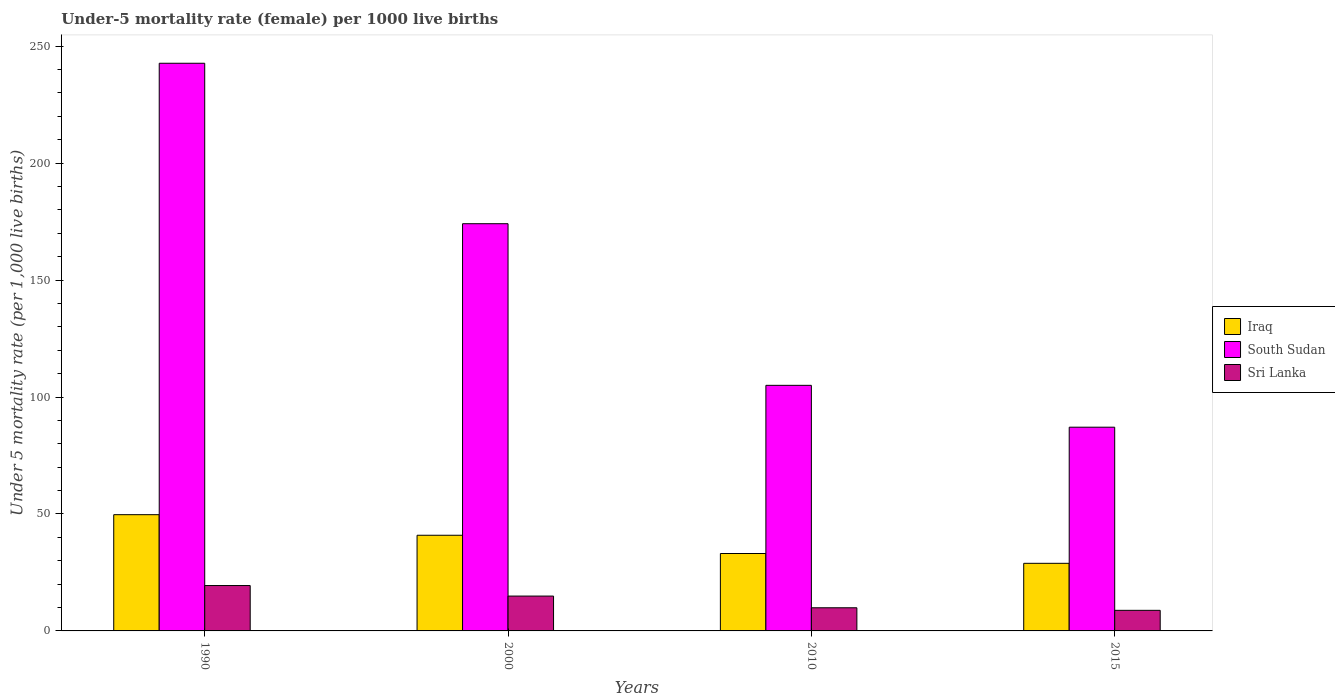How many different coloured bars are there?
Your answer should be compact. 3. Are the number of bars on each tick of the X-axis equal?
Ensure brevity in your answer.  Yes. What is the label of the 1st group of bars from the left?
Offer a terse response. 1990. In which year was the under-five mortality rate in Iraq minimum?
Your answer should be very brief. 2015. What is the total under-five mortality rate in South Sudan in the graph?
Offer a terse response. 608.9. What is the difference between the under-five mortality rate in Iraq in 2000 and that in 2010?
Keep it short and to the point. 7.8. What is the difference between the under-five mortality rate in South Sudan in 2010 and the under-five mortality rate in Sri Lanka in 2015?
Your answer should be compact. 96.2. What is the average under-five mortality rate in South Sudan per year?
Ensure brevity in your answer.  152.22. In the year 2015, what is the difference between the under-five mortality rate in Sri Lanka and under-five mortality rate in Iraq?
Your answer should be compact. -20.1. In how many years, is the under-five mortality rate in South Sudan greater than 170?
Your answer should be very brief. 2. What is the ratio of the under-five mortality rate in Iraq in 1990 to that in 2010?
Your answer should be compact. 1.5. Is the under-five mortality rate in South Sudan in 2000 less than that in 2015?
Provide a succinct answer. No. What is the difference between the highest and the second highest under-five mortality rate in South Sudan?
Your answer should be compact. 68.6. What is the difference between the highest and the lowest under-five mortality rate in Sri Lanka?
Offer a very short reply. 10.6. What does the 1st bar from the left in 2000 represents?
Provide a short and direct response. Iraq. What does the 1st bar from the right in 2015 represents?
Offer a terse response. Sri Lanka. How many years are there in the graph?
Make the answer very short. 4. Are the values on the major ticks of Y-axis written in scientific E-notation?
Your response must be concise. No. Does the graph contain any zero values?
Ensure brevity in your answer.  No. Does the graph contain grids?
Your answer should be very brief. No. Where does the legend appear in the graph?
Offer a terse response. Center right. How many legend labels are there?
Give a very brief answer. 3. How are the legend labels stacked?
Your response must be concise. Vertical. What is the title of the graph?
Make the answer very short. Under-5 mortality rate (female) per 1000 live births. What is the label or title of the X-axis?
Ensure brevity in your answer.  Years. What is the label or title of the Y-axis?
Your answer should be compact. Under 5 mortality rate (per 1,0 live births). What is the Under 5 mortality rate (per 1,000 live births) of Iraq in 1990?
Offer a very short reply. 49.7. What is the Under 5 mortality rate (per 1,000 live births) of South Sudan in 1990?
Offer a terse response. 242.7. What is the Under 5 mortality rate (per 1,000 live births) in Sri Lanka in 1990?
Your answer should be compact. 19.4. What is the Under 5 mortality rate (per 1,000 live births) of Iraq in 2000?
Give a very brief answer. 40.9. What is the Under 5 mortality rate (per 1,000 live births) of South Sudan in 2000?
Offer a terse response. 174.1. What is the Under 5 mortality rate (per 1,000 live births) in Sri Lanka in 2000?
Your response must be concise. 14.9. What is the Under 5 mortality rate (per 1,000 live births) of Iraq in 2010?
Give a very brief answer. 33.1. What is the Under 5 mortality rate (per 1,000 live births) in South Sudan in 2010?
Provide a succinct answer. 105. What is the Under 5 mortality rate (per 1,000 live births) in Sri Lanka in 2010?
Make the answer very short. 9.9. What is the Under 5 mortality rate (per 1,000 live births) of Iraq in 2015?
Your response must be concise. 28.9. What is the Under 5 mortality rate (per 1,000 live births) in South Sudan in 2015?
Your answer should be very brief. 87.1. Across all years, what is the maximum Under 5 mortality rate (per 1,000 live births) of Iraq?
Provide a succinct answer. 49.7. Across all years, what is the maximum Under 5 mortality rate (per 1,000 live births) of South Sudan?
Make the answer very short. 242.7. Across all years, what is the maximum Under 5 mortality rate (per 1,000 live births) of Sri Lanka?
Your response must be concise. 19.4. Across all years, what is the minimum Under 5 mortality rate (per 1,000 live births) of Iraq?
Provide a short and direct response. 28.9. Across all years, what is the minimum Under 5 mortality rate (per 1,000 live births) of South Sudan?
Provide a succinct answer. 87.1. What is the total Under 5 mortality rate (per 1,000 live births) in Iraq in the graph?
Keep it short and to the point. 152.6. What is the total Under 5 mortality rate (per 1,000 live births) in South Sudan in the graph?
Give a very brief answer. 608.9. What is the total Under 5 mortality rate (per 1,000 live births) in Sri Lanka in the graph?
Your answer should be compact. 53. What is the difference between the Under 5 mortality rate (per 1,000 live births) of Iraq in 1990 and that in 2000?
Your response must be concise. 8.8. What is the difference between the Under 5 mortality rate (per 1,000 live births) in South Sudan in 1990 and that in 2000?
Offer a terse response. 68.6. What is the difference between the Under 5 mortality rate (per 1,000 live births) in Sri Lanka in 1990 and that in 2000?
Offer a terse response. 4.5. What is the difference between the Under 5 mortality rate (per 1,000 live births) in Iraq in 1990 and that in 2010?
Provide a succinct answer. 16.6. What is the difference between the Under 5 mortality rate (per 1,000 live births) of South Sudan in 1990 and that in 2010?
Your response must be concise. 137.7. What is the difference between the Under 5 mortality rate (per 1,000 live births) in Iraq in 1990 and that in 2015?
Give a very brief answer. 20.8. What is the difference between the Under 5 mortality rate (per 1,000 live births) in South Sudan in 1990 and that in 2015?
Make the answer very short. 155.6. What is the difference between the Under 5 mortality rate (per 1,000 live births) in South Sudan in 2000 and that in 2010?
Your answer should be compact. 69.1. What is the difference between the Under 5 mortality rate (per 1,000 live births) in Sri Lanka in 2000 and that in 2010?
Your answer should be very brief. 5. What is the difference between the Under 5 mortality rate (per 1,000 live births) of South Sudan in 2000 and that in 2015?
Provide a short and direct response. 87. What is the difference between the Under 5 mortality rate (per 1,000 live births) of Sri Lanka in 2000 and that in 2015?
Keep it short and to the point. 6.1. What is the difference between the Under 5 mortality rate (per 1,000 live births) of South Sudan in 2010 and that in 2015?
Provide a succinct answer. 17.9. What is the difference between the Under 5 mortality rate (per 1,000 live births) of Sri Lanka in 2010 and that in 2015?
Provide a succinct answer. 1.1. What is the difference between the Under 5 mortality rate (per 1,000 live births) in Iraq in 1990 and the Under 5 mortality rate (per 1,000 live births) in South Sudan in 2000?
Your answer should be very brief. -124.4. What is the difference between the Under 5 mortality rate (per 1,000 live births) in Iraq in 1990 and the Under 5 mortality rate (per 1,000 live births) in Sri Lanka in 2000?
Give a very brief answer. 34.8. What is the difference between the Under 5 mortality rate (per 1,000 live births) of South Sudan in 1990 and the Under 5 mortality rate (per 1,000 live births) of Sri Lanka in 2000?
Provide a short and direct response. 227.8. What is the difference between the Under 5 mortality rate (per 1,000 live births) of Iraq in 1990 and the Under 5 mortality rate (per 1,000 live births) of South Sudan in 2010?
Make the answer very short. -55.3. What is the difference between the Under 5 mortality rate (per 1,000 live births) of Iraq in 1990 and the Under 5 mortality rate (per 1,000 live births) of Sri Lanka in 2010?
Ensure brevity in your answer.  39.8. What is the difference between the Under 5 mortality rate (per 1,000 live births) of South Sudan in 1990 and the Under 5 mortality rate (per 1,000 live births) of Sri Lanka in 2010?
Offer a terse response. 232.8. What is the difference between the Under 5 mortality rate (per 1,000 live births) of Iraq in 1990 and the Under 5 mortality rate (per 1,000 live births) of South Sudan in 2015?
Make the answer very short. -37.4. What is the difference between the Under 5 mortality rate (per 1,000 live births) in Iraq in 1990 and the Under 5 mortality rate (per 1,000 live births) in Sri Lanka in 2015?
Offer a terse response. 40.9. What is the difference between the Under 5 mortality rate (per 1,000 live births) of South Sudan in 1990 and the Under 5 mortality rate (per 1,000 live births) of Sri Lanka in 2015?
Keep it short and to the point. 233.9. What is the difference between the Under 5 mortality rate (per 1,000 live births) in Iraq in 2000 and the Under 5 mortality rate (per 1,000 live births) in South Sudan in 2010?
Your response must be concise. -64.1. What is the difference between the Under 5 mortality rate (per 1,000 live births) of Iraq in 2000 and the Under 5 mortality rate (per 1,000 live births) of Sri Lanka in 2010?
Offer a terse response. 31. What is the difference between the Under 5 mortality rate (per 1,000 live births) of South Sudan in 2000 and the Under 5 mortality rate (per 1,000 live births) of Sri Lanka in 2010?
Keep it short and to the point. 164.2. What is the difference between the Under 5 mortality rate (per 1,000 live births) in Iraq in 2000 and the Under 5 mortality rate (per 1,000 live births) in South Sudan in 2015?
Your answer should be very brief. -46.2. What is the difference between the Under 5 mortality rate (per 1,000 live births) of Iraq in 2000 and the Under 5 mortality rate (per 1,000 live births) of Sri Lanka in 2015?
Ensure brevity in your answer.  32.1. What is the difference between the Under 5 mortality rate (per 1,000 live births) of South Sudan in 2000 and the Under 5 mortality rate (per 1,000 live births) of Sri Lanka in 2015?
Provide a short and direct response. 165.3. What is the difference between the Under 5 mortality rate (per 1,000 live births) in Iraq in 2010 and the Under 5 mortality rate (per 1,000 live births) in South Sudan in 2015?
Provide a succinct answer. -54. What is the difference between the Under 5 mortality rate (per 1,000 live births) in Iraq in 2010 and the Under 5 mortality rate (per 1,000 live births) in Sri Lanka in 2015?
Keep it short and to the point. 24.3. What is the difference between the Under 5 mortality rate (per 1,000 live births) in South Sudan in 2010 and the Under 5 mortality rate (per 1,000 live births) in Sri Lanka in 2015?
Offer a terse response. 96.2. What is the average Under 5 mortality rate (per 1,000 live births) of Iraq per year?
Give a very brief answer. 38.15. What is the average Under 5 mortality rate (per 1,000 live births) in South Sudan per year?
Make the answer very short. 152.22. What is the average Under 5 mortality rate (per 1,000 live births) of Sri Lanka per year?
Your response must be concise. 13.25. In the year 1990, what is the difference between the Under 5 mortality rate (per 1,000 live births) in Iraq and Under 5 mortality rate (per 1,000 live births) in South Sudan?
Your answer should be compact. -193. In the year 1990, what is the difference between the Under 5 mortality rate (per 1,000 live births) of Iraq and Under 5 mortality rate (per 1,000 live births) of Sri Lanka?
Give a very brief answer. 30.3. In the year 1990, what is the difference between the Under 5 mortality rate (per 1,000 live births) in South Sudan and Under 5 mortality rate (per 1,000 live births) in Sri Lanka?
Make the answer very short. 223.3. In the year 2000, what is the difference between the Under 5 mortality rate (per 1,000 live births) in Iraq and Under 5 mortality rate (per 1,000 live births) in South Sudan?
Your answer should be very brief. -133.2. In the year 2000, what is the difference between the Under 5 mortality rate (per 1,000 live births) in Iraq and Under 5 mortality rate (per 1,000 live births) in Sri Lanka?
Your answer should be very brief. 26. In the year 2000, what is the difference between the Under 5 mortality rate (per 1,000 live births) in South Sudan and Under 5 mortality rate (per 1,000 live births) in Sri Lanka?
Make the answer very short. 159.2. In the year 2010, what is the difference between the Under 5 mortality rate (per 1,000 live births) in Iraq and Under 5 mortality rate (per 1,000 live births) in South Sudan?
Your answer should be very brief. -71.9. In the year 2010, what is the difference between the Under 5 mortality rate (per 1,000 live births) in Iraq and Under 5 mortality rate (per 1,000 live births) in Sri Lanka?
Offer a very short reply. 23.2. In the year 2010, what is the difference between the Under 5 mortality rate (per 1,000 live births) in South Sudan and Under 5 mortality rate (per 1,000 live births) in Sri Lanka?
Keep it short and to the point. 95.1. In the year 2015, what is the difference between the Under 5 mortality rate (per 1,000 live births) of Iraq and Under 5 mortality rate (per 1,000 live births) of South Sudan?
Your response must be concise. -58.2. In the year 2015, what is the difference between the Under 5 mortality rate (per 1,000 live births) of Iraq and Under 5 mortality rate (per 1,000 live births) of Sri Lanka?
Your answer should be very brief. 20.1. In the year 2015, what is the difference between the Under 5 mortality rate (per 1,000 live births) of South Sudan and Under 5 mortality rate (per 1,000 live births) of Sri Lanka?
Your response must be concise. 78.3. What is the ratio of the Under 5 mortality rate (per 1,000 live births) in Iraq in 1990 to that in 2000?
Your response must be concise. 1.22. What is the ratio of the Under 5 mortality rate (per 1,000 live births) of South Sudan in 1990 to that in 2000?
Offer a terse response. 1.39. What is the ratio of the Under 5 mortality rate (per 1,000 live births) of Sri Lanka in 1990 to that in 2000?
Ensure brevity in your answer.  1.3. What is the ratio of the Under 5 mortality rate (per 1,000 live births) of Iraq in 1990 to that in 2010?
Your answer should be compact. 1.5. What is the ratio of the Under 5 mortality rate (per 1,000 live births) of South Sudan in 1990 to that in 2010?
Make the answer very short. 2.31. What is the ratio of the Under 5 mortality rate (per 1,000 live births) in Sri Lanka in 1990 to that in 2010?
Offer a very short reply. 1.96. What is the ratio of the Under 5 mortality rate (per 1,000 live births) of Iraq in 1990 to that in 2015?
Your response must be concise. 1.72. What is the ratio of the Under 5 mortality rate (per 1,000 live births) of South Sudan in 1990 to that in 2015?
Your answer should be very brief. 2.79. What is the ratio of the Under 5 mortality rate (per 1,000 live births) of Sri Lanka in 1990 to that in 2015?
Make the answer very short. 2.2. What is the ratio of the Under 5 mortality rate (per 1,000 live births) in Iraq in 2000 to that in 2010?
Ensure brevity in your answer.  1.24. What is the ratio of the Under 5 mortality rate (per 1,000 live births) of South Sudan in 2000 to that in 2010?
Your answer should be compact. 1.66. What is the ratio of the Under 5 mortality rate (per 1,000 live births) of Sri Lanka in 2000 to that in 2010?
Keep it short and to the point. 1.51. What is the ratio of the Under 5 mortality rate (per 1,000 live births) of Iraq in 2000 to that in 2015?
Give a very brief answer. 1.42. What is the ratio of the Under 5 mortality rate (per 1,000 live births) in South Sudan in 2000 to that in 2015?
Your answer should be very brief. 2. What is the ratio of the Under 5 mortality rate (per 1,000 live births) in Sri Lanka in 2000 to that in 2015?
Keep it short and to the point. 1.69. What is the ratio of the Under 5 mortality rate (per 1,000 live births) of Iraq in 2010 to that in 2015?
Your answer should be compact. 1.15. What is the ratio of the Under 5 mortality rate (per 1,000 live births) in South Sudan in 2010 to that in 2015?
Provide a succinct answer. 1.21. What is the difference between the highest and the second highest Under 5 mortality rate (per 1,000 live births) in South Sudan?
Keep it short and to the point. 68.6. What is the difference between the highest and the second highest Under 5 mortality rate (per 1,000 live births) in Sri Lanka?
Provide a short and direct response. 4.5. What is the difference between the highest and the lowest Under 5 mortality rate (per 1,000 live births) of Iraq?
Provide a short and direct response. 20.8. What is the difference between the highest and the lowest Under 5 mortality rate (per 1,000 live births) in South Sudan?
Keep it short and to the point. 155.6. What is the difference between the highest and the lowest Under 5 mortality rate (per 1,000 live births) in Sri Lanka?
Give a very brief answer. 10.6. 